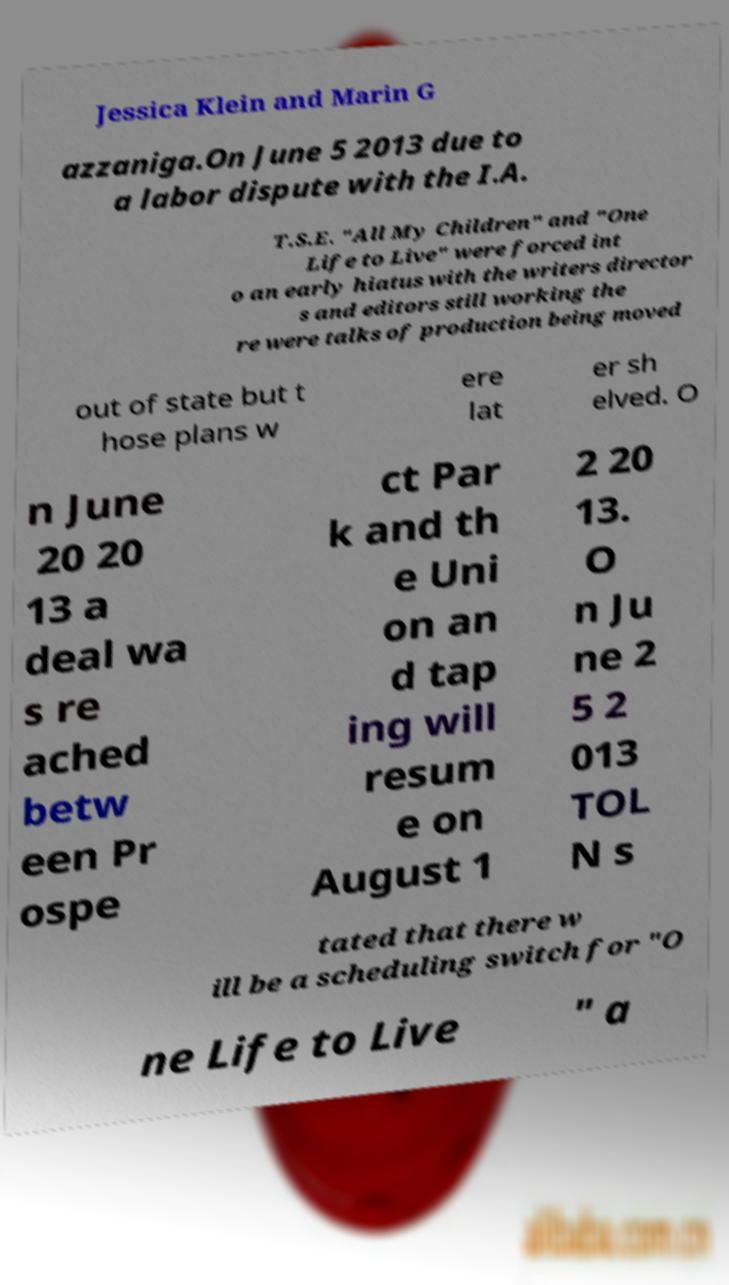Could you extract and type out the text from this image? Jessica Klein and Marin G azzaniga.On June 5 2013 due to a labor dispute with the I.A. T.S.E. "All My Children" and "One Life to Live" were forced int o an early hiatus with the writers director s and editors still working the re were talks of production being moved out of state but t hose plans w ere lat er sh elved. O n June 20 20 13 a deal wa s re ached betw een Pr ospe ct Par k and th e Uni on an d tap ing will resum e on August 1 2 20 13. O n Ju ne 2 5 2 013 TOL N s tated that there w ill be a scheduling switch for "O ne Life to Live " a 